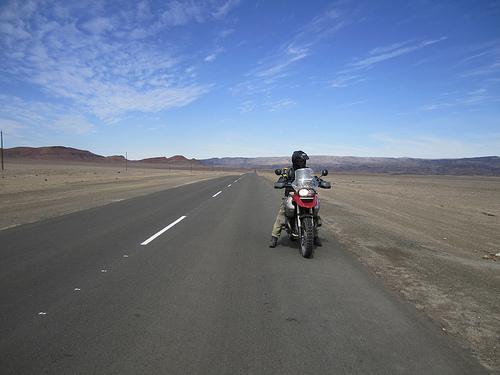How many motorbikes are in the photo?
Give a very brief answer. 1. 